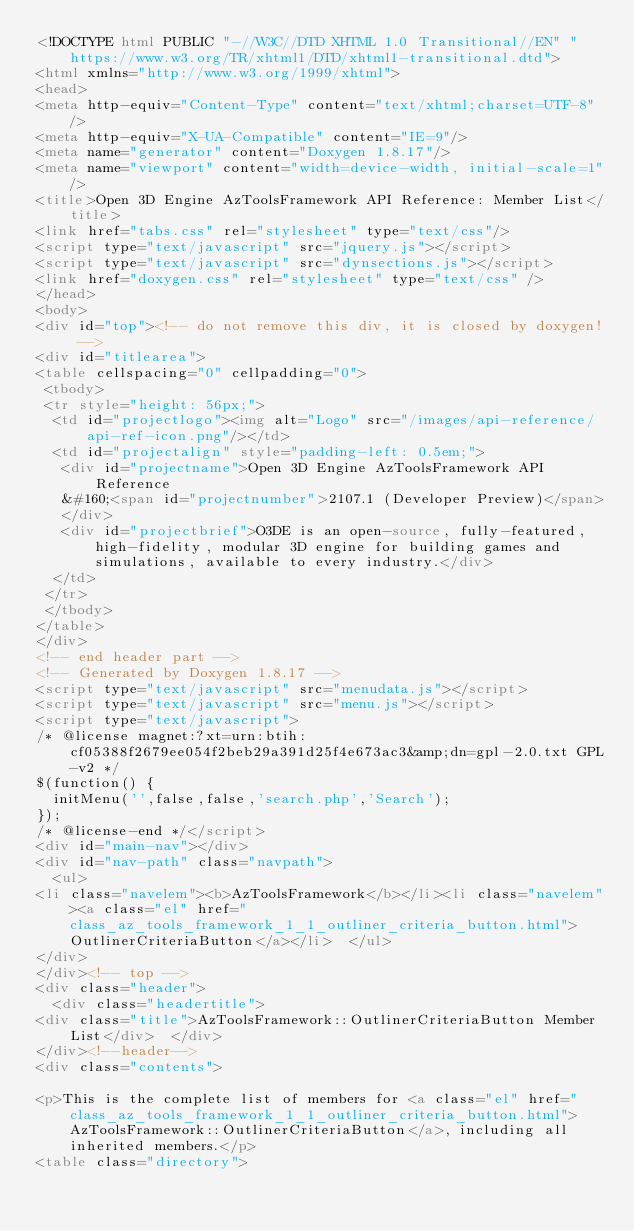<code> <loc_0><loc_0><loc_500><loc_500><_HTML_><!DOCTYPE html PUBLIC "-//W3C//DTD XHTML 1.0 Transitional//EN" "https://www.w3.org/TR/xhtml1/DTD/xhtml1-transitional.dtd">
<html xmlns="http://www.w3.org/1999/xhtml">
<head>
<meta http-equiv="Content-Type" content="text/xhtml;charset=UTF-8"/>
<meta http-equiv="X-UA-Compatible" content="IE=9"/>
<meta name="generator" content="Doxygen 1.8.17"/>
<meta name="viewport" content="width=device-width, initial-scale=1"/>
<title>Open 3D Engine AzToolsFramework API Reference: Member List</title>
<link href="tabs.css" rel="stylesheet" type="text/css"/>
<script type="text/javascript" src="jquery.js"></script>
<script type="text/javascript" src="dynsections.js"></script>
<link href="doxygen.css" rel="stylesheet" type="text/css" />
</head>
<body>
<div id="top"><!-- do not remove this div, it is closed by doxygen! -->
<div id="titlearea">
<table cellspacing="0" cellpadding="0">
 <tbody>
 <tr style="height: 56px;">
  <td id="projectlogo"><img alt="Logo" src="/images/api-reference/api-ref-icon.png"/></td>
  <td id="projectalign" style="padding-left: 0.5em;">
   <div id="projectname">Open 3D Engine AzToolsFramework API Reference
   &#160;<span id="projectnumber">2107.1 (Developer Preview)</span>
   </div>
   <div id="projectbrief">O3DE is an open-source, fully-featured, high-fidelity, modular 3D engine for building games and simulations, available to every industry.</div>
  </td>
 </tr>
 </tbody>
</table>
</div>
<!-- end header part -->
<!-- Generated by Doxygen 1.8.17 -->
<script type="text/javascript" src="menudata.js"></script>
<script type="text/javascript" src="menu.js"></script>
<script type="text/javascript">
/* @license magnet:?xt=urn:btih:cf05388f2679ee054f2beb29a391d25f4e673ac3&amp;dn=gpl-2.0.txt GPL-v2 */
$(function() {
  initMenu('',false,false,'search.php','Search');
});
/* @license-end */</script>
<div id="main-nav"></div>
<div id="nav-path" class="navpath">
  <ul>
<li class="navelem"><b>AzToolsFramework</b></li><li class="navelem"><a class="el" href="class_az_tools_framework_1_1_outliner_criteria_button.html">OutlinerCriteriaButton</a></li>  </ul>
</div>
</div><!-- top -->
<div class="header">
  <div class="headertitle">
<div class="title">AzToolsFramework::OutlinerCriteriaButton Member List</div>  </div>
</div><!--header-->
<div class="contents">

<p>This is the complete list of members for <a class="el" href="class_az_tools_framework_1_1_outliner_criteria_button.html">AzToolsFramework::OutlinerCriteriaButton</a>, including all inherited members.</p>
<table class="directory"></code> 